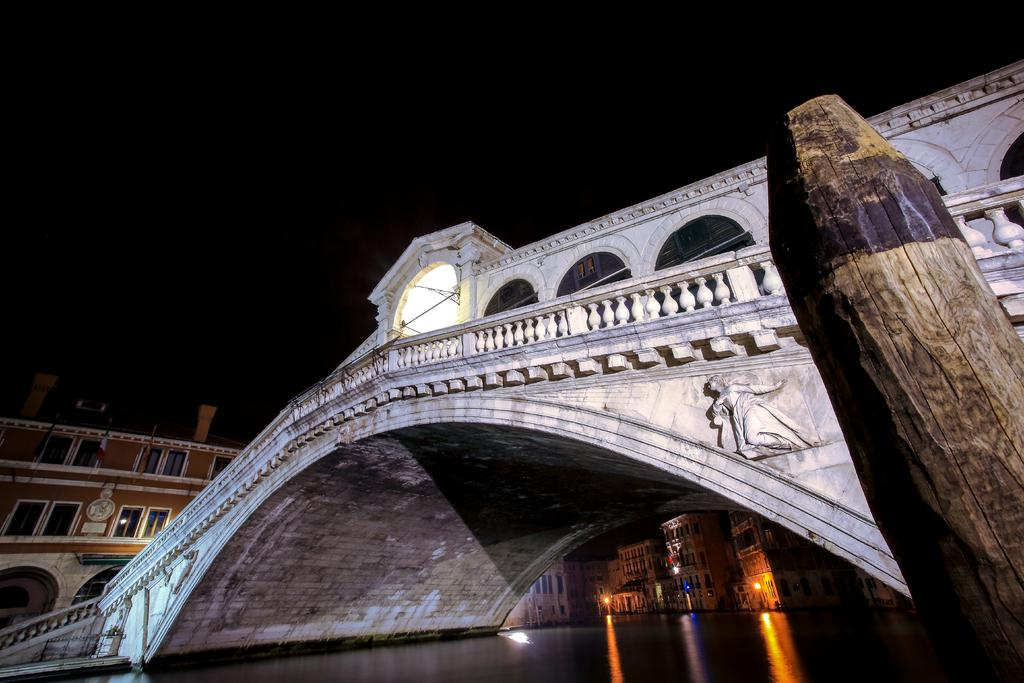What type of wall is on the right side of the image? There is a wooden wall on the right side of the image. What is the main feature in the image? There is a bridgewater in the image. What type of structures can be seen in the image? There are buildings in the image. What can be used for illumination in the image? Lights are visible in the image. What is the color of the sky in the background of the image? The sky in the background of the image is dark. How many windows are visible in the image? There is no mention of windows in the provided facts, so we cannot determine the number of windows in the image. 